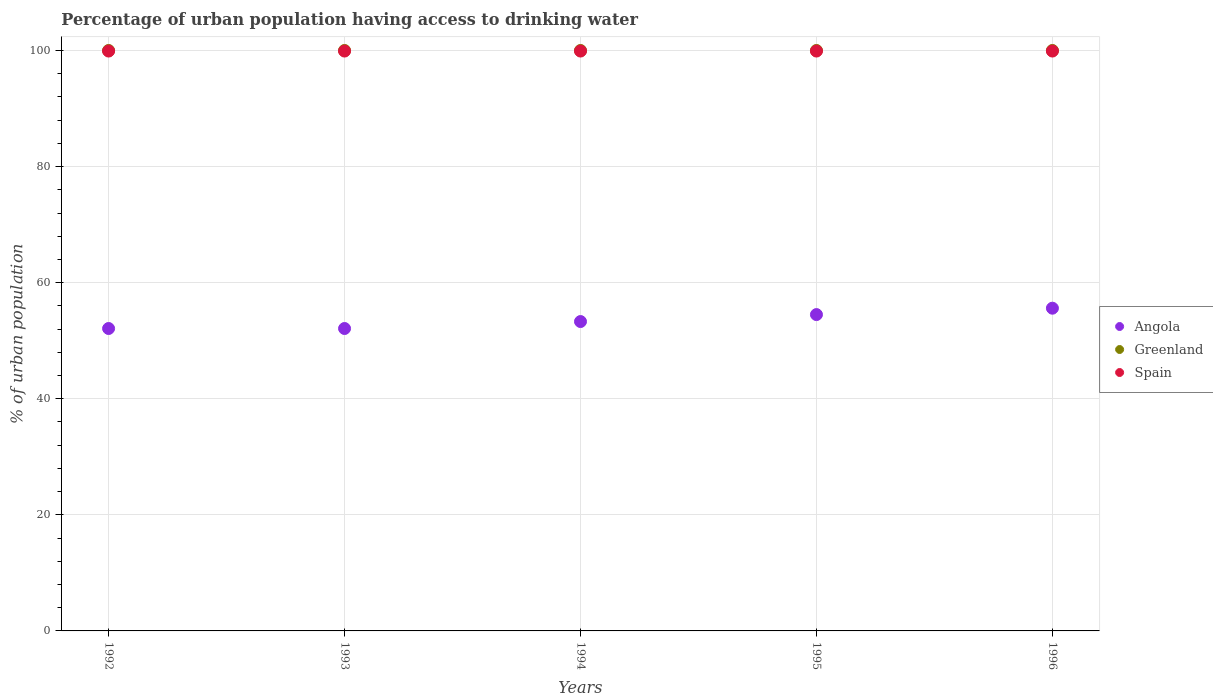What is the percentage of urban population having access to drinking water in Greenland in 1992?
Your answer should be very brief. 100. Across all years, what is the maximum percentage of urban population having access to drinking water in Angola?
Your answer should be very brief. 55.6. Across all years, what is the minimum percentage of urban population having access to drinking water in Spain?
Offer a very short reply. 99.9. In which year was the percentage of urban population having access to drinking water in Greenland minimum?
Your response must be concise. 1992. What is the total percentage of urban population having access to drinking water in Angola in the graph?
Your answer should be compact. 267.6. What is the difference between the percentage of urban population having access to drinking water in Greenland in 1992 and that in 1996?
Give a very brief answer. 0. What is the difference between the percentage of urban population having access to drinking water in Angola in 1994 and the percentage of urban population having access to drinking water in Greenland in 1996?
Give a very brief answer. -46.7. What is the average percentage of urban population having access to drinking water in Angola per year?
Offer a terse response. 53.52. In the year 1993, what is the difference between the percentage of urban population having access to drinking water in Greenland and percentage of urban population having access to drinking water in Angola?
Your response must be concise. 47.9. In how many years, is the percentage of urban population having access to drinking water in Spain greater than 20 %?
Your answer should be compact. 5. Is the percentage of urban population having access to drinking water in Greenland in 1992 less than that in 1993?
Your answer should be very brief. No. Is the difference between the percentage of urban population having access to drinking water in Greenland in 1993 and 1996 greater than the difference between the percentage of urban population having access to drinking water in Angola in 1993 and 1996?
Your answer should be very brief. Yes. What is the difference between the highest and the second highest percentage of urban population having access to drinking water in Angola?
Your answer should be compact. 1.1. What is the difference between the highest and the lowest percentage of urban population having access to drinking water in Spain?
Keep it short and to the point. 0. Is the sum of the percentage of urban population having access to drinking water in Greenland in 1994 and 1996 greater than the maximum percentage of urban population having access to drinking water in Spain across all years?
Give a very brief answer. Yes. Is it the case that in every year, the sum of the percentage of urban population having access to drinking water in Angola and percentage of urban population having access to drinking water in Greenland  is greater than the percentage of urban population having access to drinking water in Spain?
Provide a short and direct response. Yes. Is the percentage of urban population having access to drinking water in Greenland strictly greater than the percentage of urban population having access to drinking water in Spain over the years?
Make the answer very short. Yes. Is the percentage of urban population having access to drinking water in Angola strictly less than the percentage of urban population having access to drinking water in Spain over the years?
Ensure brevity in your answer.  Yes. How many years are there in the graph?
Your response must be concise. 5. Does the graph contain any zero values?
Keep it short and to the point. No. Does the graph contain grids?
Your response must be concise. Yes. How are the legend labels stacked?
Give a very brief answer. Vertical. What is the title of the graph?
Give a very brief answer. Percentage of urban population having access to drinking water. Does "Belize" appear as one of the legend labels in the graph?
Your answer should be very brief. No. What is the label or title of the Y-axis?
Your answer should be very brief. % of urban population. What is the % of urban population of Angola in 1992?
Offer a terse response. 52.1. What is the % of urban population of Spain in 1992?
Provide a short and direct response. 99.9. What is the % of urban population in Angola in 1993?
Offer a very short reply. 52.1. What is the % of urban population of Greenland in 1993?
Offer a terse response. 100. What is the % of urban population of Spain in 1993?
Your answer should be very brief. 99.9. What is the % of urban population in Angola in 1994?
Ensure brevity in your answer.  53.3. What is the % of urban population of Spain in 1994?
Make the answer very short. 99.9. What is the % of urban population in Angola in 1995?
Your answer should be compact. 54.5. What is the % of urban population in Greenland in 1995?
Ensure brevity in your answer.  100. What is the % of urban population of Spain in 1995?
Provide a short and direct response. 99.9. What is the % of urban population in Angola in 1996?
Provide a short and direct response. 55.6. What is the % of urban population of Greenland in 1996?
Ensure brevity in your answer.  100. What is the % of urban population of Spain in 1996?
Your response must be concise. 99.9. Across all years, what is the maximum % of urban population in Angola?
Offer a terse response. 55.6. Across all years, what is the maximum % of urban population in Greenland?
Provide a short and direct response. 100. Across all years, what is the maximum % of urban population of Spain?
Make the answer very short. 99.9. Across all years, what is the minimum % of urban population in Angola?
Your response must be concise. 52.1. Across all years, what is the minimum % of urban population in Greenland?
Your response must be concise. 100. Across all years, what is the minimum % of urban population in Spain?
Provide a succinct answer. 99.9. What is the total % of urban population in Angola in the graph?
Give a very brief answer. 267.6. What is the total % of urban population in Spain in the graph?
Give a very brief answer. 499.5. What is the difference between the % of urban population of Angola in 1992 and that in 1993?
Your answer should be very brief. 0. What is the difference between the % of urban population in Greenland in 1992 and that in 1993?
Ensure brevity in your answer.  0. What is the difference between the % of urban population in Angola in 1992 and that in 1994?
Make the answer very short. -1.2. What is the difference between the % of urban population of Greenland in 1992 and that in 1994?
Offer a very short reply. 0. What is the difference between the % of urban population in Spain in 1992 and that in 1994?
Ensure brevity in your answer.  0. What is the difference between the % of urban population in Angola in 1992 and that in 1995?
Make the answer very short. -2.4. What is the difference between the % of urban population of Greenland in 1992 and that in 1995?
Give a very brief answer. 0. What is the difference between the % of urban population in Angola in 1992 and that in 1996?
Make the answer very short. -3.5. What is the difference between the % of urban population of Greenland in 1992 and that in 1996?
Your answer should be very brief. 0. What is the difference between the % of urban population in Spain in 1992 and that in 1996?
Offer a terse response. 0. What is the difference between the % of urban population of Angola in 1993 and that in 1994?
Give a very brief answer. -1.2. What is the difference between the % of urban population of Greenland in 1993 and that in 1995?
Ensure brevity in your answer.  0. What is the difference between the % of urban population in Spain in 1993 and that in 1995?
Your response must be concise. 0. What is the difference between the % of urban population of Angola in 1993 and that in 1996?
Offer a very short reply. -3.5. What is the difference between the % of urban population in Greenland in 1993 and that in 1996?
Give a very brief answer. 0. What is the difference between the % of urban population in Spain in 1993 and that in 1996?
Your answer should be very brief. 0. What is the difference between the % of urban population of Greenland in 1994 and that in 1995?
Your answer should be very brief. 0. What is the difference between the % of urban population of Spain in 1994 and that in 1995?
Keep it short and to the point. 0. What is the difference between the % of urban population in Spain in 1994 and that in 1996?
Make the answer very short. 0. What is the difference between the % of urban population in Angola in 1995 and that in 1996?
Provide a short and direct response. -1.1. What is the difference between the % of urban population of Greenland in 1995 and that in 1996?
Your answer should be very brief. 0. What is the difference between the % of urban population of Spain in 1995 and that in 1996?
Ensure brevity in your answer.  0. What is the difference between the % of urban population in Angola in 1992 and the % of urban population in Greenland in 1993?
Offer a terse response. -47.9. What is the difference between the % of urban population in Angola in 1992 and the % of urban population in Spain in 1993?
Give a very brief answer. -47.8. What is the difference between the % of urban population of Angola in 1992 and the % of urban population of Greenland in 1994?
Offer a very short reply. -47.9. What is the difference between the % of urban population in Angola in 1992 and the % of urban population in Spain in 1994?
Offer a very short reply. -47.8. What is the difference between the % of urban population of Greenland in 1992 and the % of urban population of Spain in 1994?
Offer a very short reply. 0.1. What is the difference between the % of urban population of Angola in 1992 and the % of urban population of Greenland in 1995?
Your answer should be compact. -47.9. What is the difference between the % of urban population of Angola in 1992 and the % of urban population of Spain in 1995?
Offer a terse response. -47.8. What is the difference between the % of urban population in Angola in 1992 and the % of urban population in Greenland in 1996?
Offer a terse response. -47.9. What is the difference between the % of urban population in Angola in 1992 and the % of urban population in Spain in 1996?
Keep it short and to the point. -47.8. What is the difference between the % of urban population of Angola in 1993 and the % of urban population of Greenland in 1994?
Offer a very short reply. -47.9. What is the difference between the % of urban population in Angola in 1993 and the % of urban population in Spain in 1994?
Make the answer very short. -47.8. What is the difference between the % of urban population of Angola in 1993 and the % of urban population of Greenland in 1995?
Ensure brevity in your answer.  -47.9. What is the difference between the % of urban population of Angola in 1993 and the % of urban population of Spain in 1995?
Your response must be concise. -47.8. What is the difference between the % of urban population of Angola in 1993 and the % of urban population of Greenland in 1996?
Your response must be concise. -47.9. What is the difference between the % of urban population of Angola in 1993 and the % of urban population of Spain in 1996?
Keep it short and to the point. -47.8. What is the difference between the % of urban population of Angola in 1994 and the % of urban population of Greenland in 1995?
Ensure brevity in your answer.  -46.7. What is the difference between the % of urban population in Angola in 1994 and the % of urban population in Spain in 1995?
Your answer should be very brief. -46.6. What is the difference between the % of urban population of Angola in 1994 and the % of urban population of Greenland in 1996?
Your response must be concise. -46.7. What is the difference between the % of urban population of Angola in 1994 and the % of urban population of Spain in 1996?
Ensure brevity in your answer.  -46.6. What is the difference between the % of urban population of Angola in 1995 and the % of urban population of Greenland in 1996?
Provide a succinct answer. -45.5. What is the difference between the % of urban population of Angola in 1995 and the % of urban population of Spain in 1996?
Make the answer very short. -45.4. What is the average % of urban population of Angola per year?
Provide a succinct answer. 53.52. What is the average % of urban population of Spain per year?
Provide a short and direct response. 99.9. In the year 1992, what is the difference between the % of urban population of Angola and % of urban population of Greenland?
Provide a short and direct response. -47.9. In the year 1992, what is the difference between the % of urban population of Angola and % of urban population of Spain?
Keep it short and to the point. -47.8. In the year 1993, what is the difference between the % of urban population in Angola and % of urban population in Greenland?
Make the answer very short. -47.9. In the year 1993, what is the difference between the % of urban population of Angola and % of urban population of Spain?
Give a very brief answer. -47.8. In the year 1994, what is the difference between the % of urban population in Angola and % of urban population in Greenland?
Keep it short and to the point. -46.7. In the year 1994, what is the difference between the % of urban population of Angola and % of urban population of Spain?
Offer a terse response. -46.6. In the year 1994, what is the difference between the % of urban population in Greenland and % of urban population in Spain?
Your answer should be very brief. 0.1. In the year 1995, what is the difference between the % of urban population in Angola and % of urban population in Greenland?
Your answer should be very brief. -45.5. In the year 1995, what is the difference between the % of urban population of Angola and % of urban population of Spain?
Make the answer very short. -45.4. In the year 1996, what is the difference between the % of urban population of Angola and % of urban population of Greenland?
Make the answer very short. -44.4. In the year 1996, what is the difference between the % of urban population in Angola and % of urban population in Spain?
Give a very brief answer. -44.3. What is the ratio of the % of urban population in Greenland in 1992 to that in 1993?
Ensure brevity in your answer.  1. What is the ratio of the % of urban population in Angola in 1992 to that in 1994?
Give a very brief answer. 0.98. What is the ratio of the % of urban population of Angola in 1992 to that in 1995?
Your answer should be very brief. 0.96. What is the ratio of the % of urban population in Spain in 1992 to that in 1995?
Your answer should be very brief. 1. What is the ratio of the % of urban population of Angola in 1992 to that in 1996?
Provide a succinct answer. 0.94. What is the ratio of the % of urban population in Angola in 1993 to that in 1994?
Your response must be concise. 0.98. What is the ratio of the % of urban population of Greenland in 1993 to that in 1994?
Ensure brevity in your answer.  1. What is the ratio of the % of urban population of Angola in 1993 to that in 1995?
Ensure brevity in your answer.  0.96. What is the ratio of the % of urban population of Greenland in 1993 to that in 1995?
Provide a short and direct response. 1. What is the ratio of the % of urban population of Angola in 1993 to that in 1996?
Provide a short and direct response. 0.94. What is the ratio of the % of urban population in Greenland in 1993 to that in 1996?
Your answer should be very brief. 1. What is the ratio of the % of urban population of Spain in 1993 to that in 1996?
Provide a short and direct response. 1. What is the ratio of the % of urban population in Greenland in 1994 to that in 1995?
Make the answer very short. 1. What is the ratio of the % of urban population of Angola in 1994 to that in 1996?
Your answer should be compact. 0.96. What is the ratio of the % of urban population of Angola in 1995 to that in 1996?
Your answer should be compact. 0.98. What is the ratio of the % of urban population in Greenland in 1995 to that in 1996?
Offer a very short reply. 1. What is the ratio of the % of urban population of Spain in 1995 to that in 1996?
Your answer should be compact. 1. What is the difference between the highest and the second highest % of urban population in Spain?
Make the answer very short. 0. What is the difference between the highest and the lowest % of urban population of Angola?
Your response must be concise. 3.5. What is the difference between the highest and the lowest % of urban population of Spain?
Your answer should be very brief. 0. 